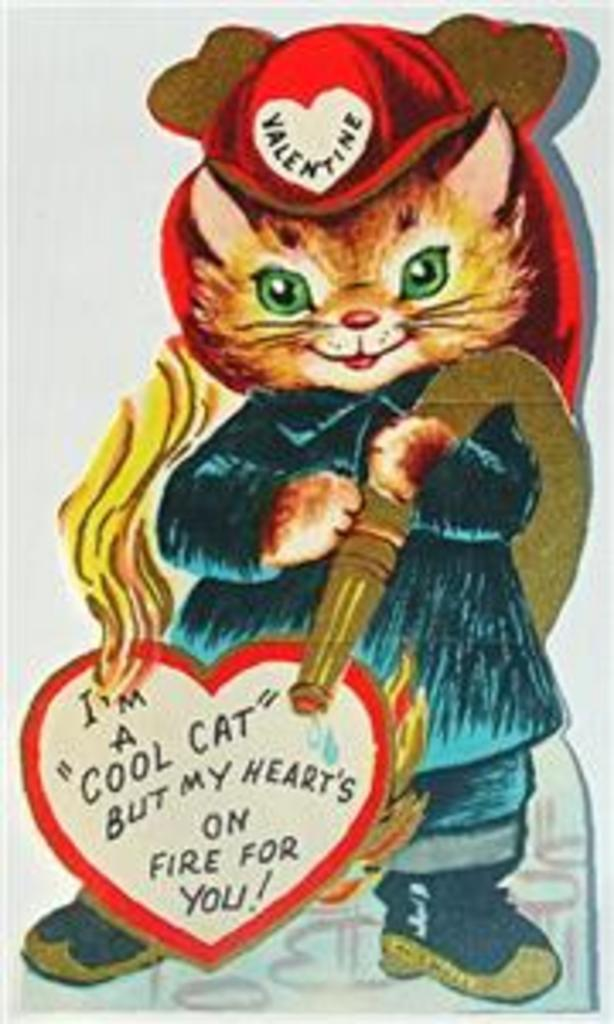What type of image is being described? The image is a cartoon picture. What animal is featured in the cartoon picture? The cartoon picture features a cat. Are there any words or phrases in the image? Yes, there is text present in the image. What type of berry is being eaten by the cat in the image? There is no berry present in the image; it is a cartoon picture featuring a cat and text. 